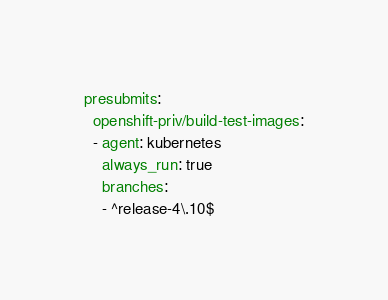Convert code to text. <code><loc_0><loc_0><loc_500><loc_500><_YAML_>presubmits:
  openshift-priv/build-test-images:
  - agent: kubernetes
    always_run: true
    branches:
    - ^release-4\.10$</code> 